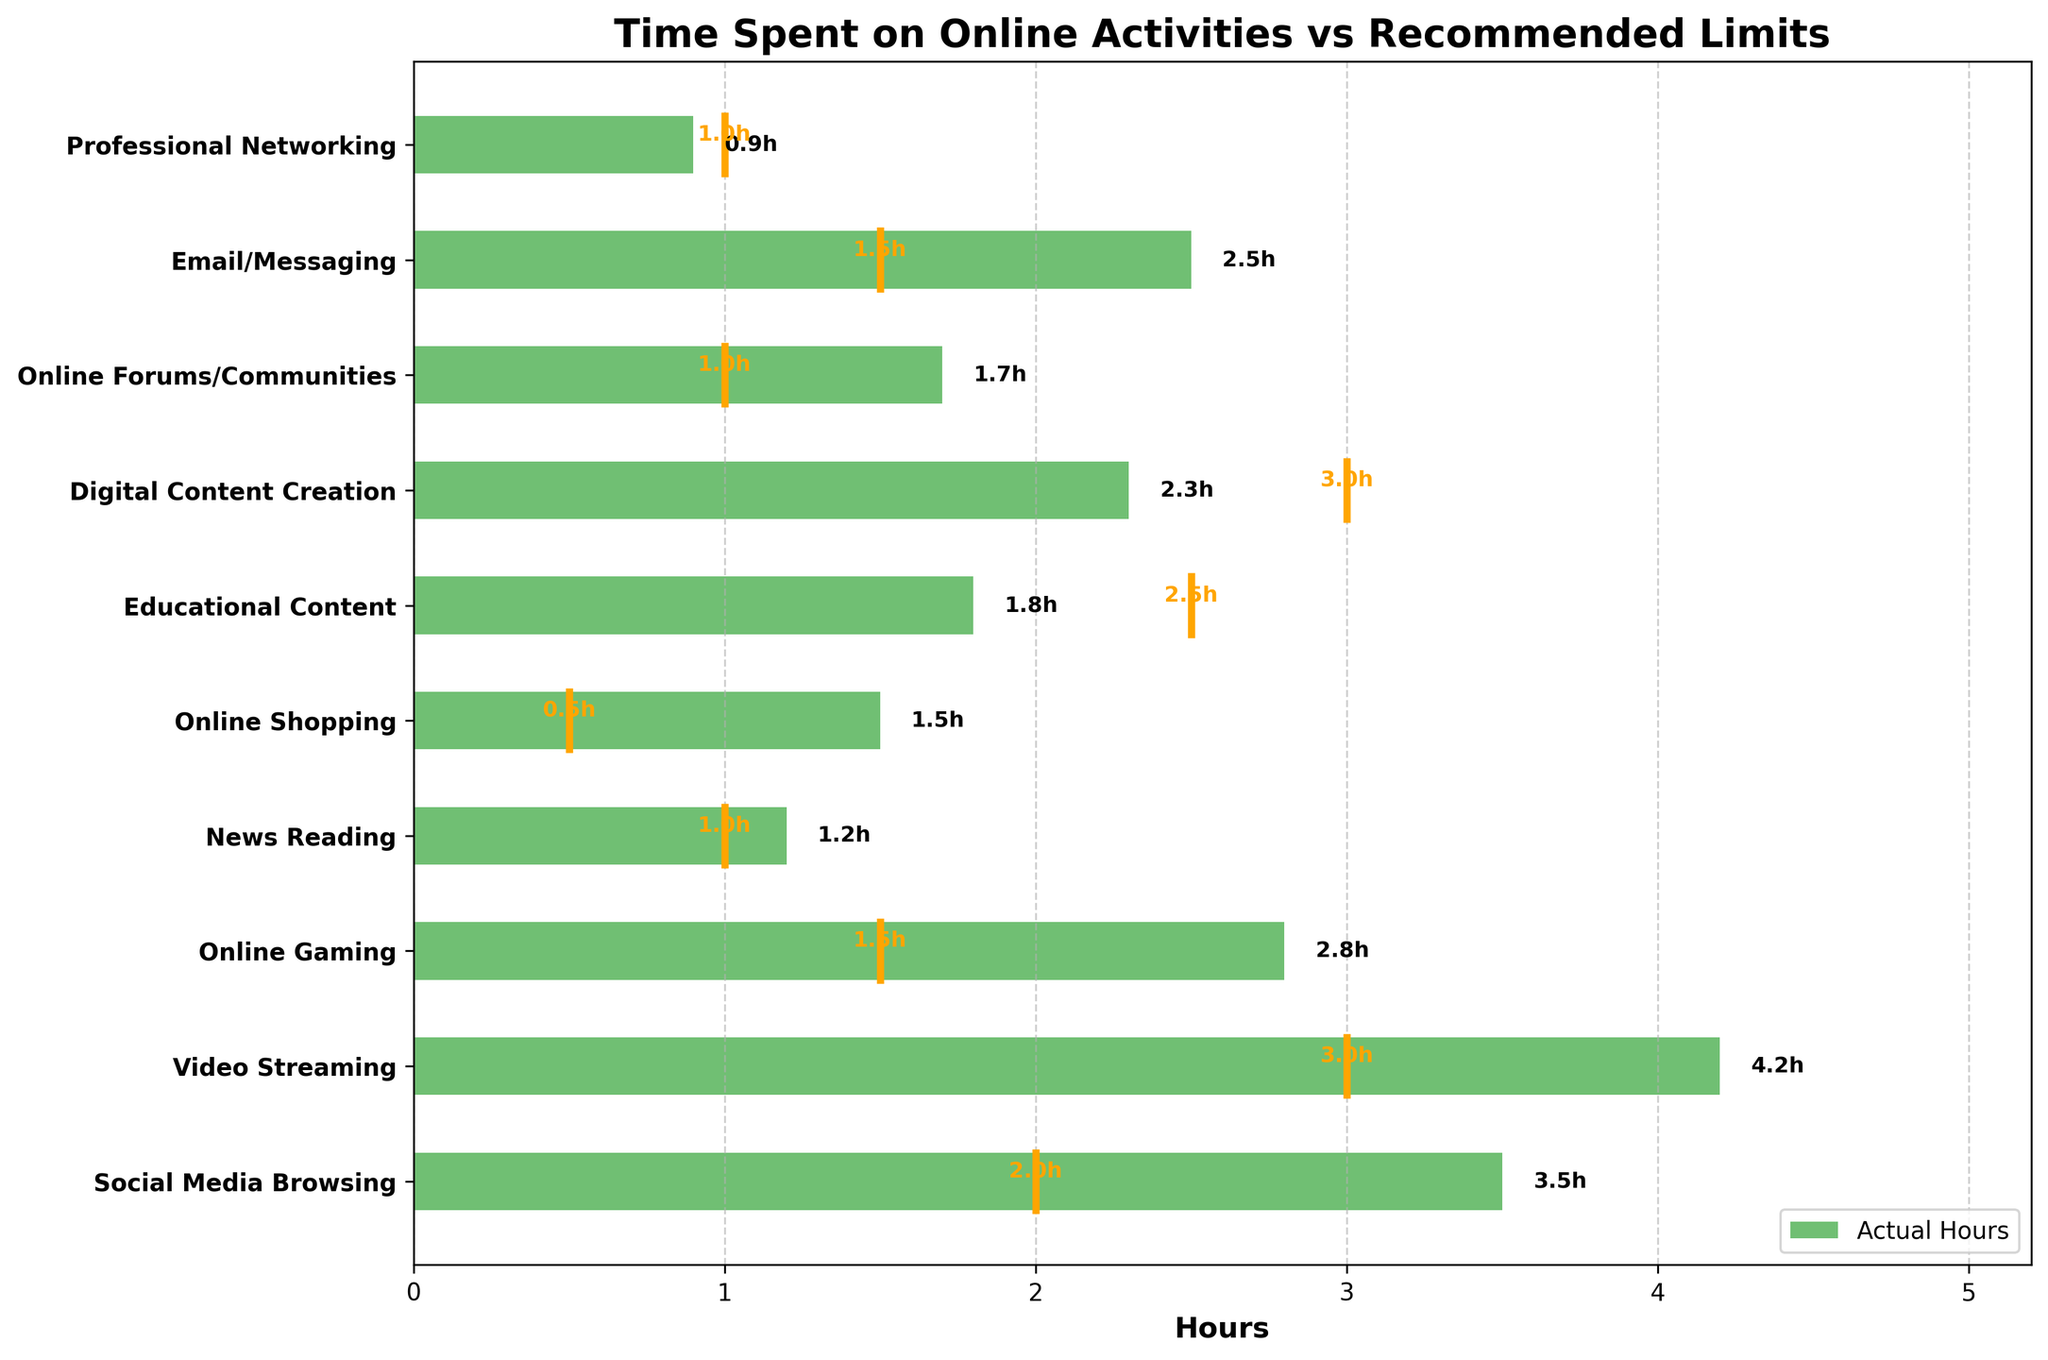What is the title of the chart? The title of the chart is typically at the top and explicitly stated. In this case, we look for that title in the chart.
Answer: Time Spent on Online Activities vs Recommended Limits How many activities exceeded their recommended limits? By comparing the bars (actual hours) with the vertical lines (recommended limits) for each activity, we can count the instances where the bar extends beyond the line.
Answer: 8 Which activity had the highest difference between actual hours and recommended limit? The difference can be calculated by subtracting the recommended limit from the actual hours for each activity. The activity with the largest positive difference is identified.
Answer: Video Streaming How much time is spent on Online Gaming compared to its recommended limit? You compare the bar (actual hours) to the vertical line (recommended limit) for Online Gaming. The chart shows 2.8 hours, and the recommended limit is 1.5 hours.
Answer: 2.8 hours compared to 1.5 hours Which activities are within or below their recommended limits? Activities that have bars that do not exceed their corresponding vertical lines are within or below their recommended limits.
Answer: News Reading, Educational Content, Professional Networking What is the combined total of all actual hours spent on online activities? Sum the actual hours for all activities to get the total. Adding: 3.5 + 4.2 + 2.8 + 1.2 + 1.5 + 1.8 + 2.3 + 1.7 + 2.5 + 0.9.
Answer: 22.4 hours What is the average recommended limit across all activities? Calculate the average by summing all recommended limits and dividing by the number of activities. Adding: 2 + 3 + 1.5 + 1 + 0.5 + 2.5 + 3 + 1 + 1.5 + 1 = 17, then dividing by 10 activities.
Answer: 1.7 hours Which two activities have the closest actual hours spent? By comparing the actual hours for each activity pair-wise, we identify the two with the smallest numerical difference.
Answer: Online Forums/Communities and News Reading On which activity is the least time spent, and how does it compare to its recommended limit? Identify the activity with the smallest bar. Then compare this value to the activity's vertical line.
Answer: Professional Networking, 0.9 hours compared to 1 hour 